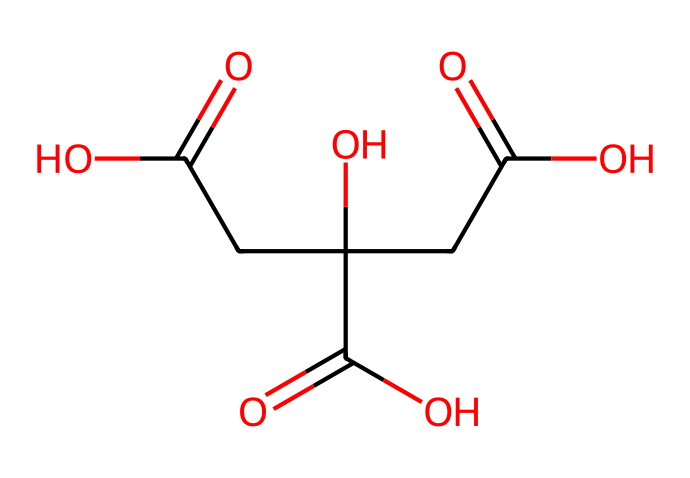What is the molecular formula of citric acid? The SMILES representation can be analyzed to determine the number of each type of atom present. Counting from the SMILES, we identify 6 carbon (C), 8 hydrogen (H), and 7 oxygen (O) atoms. Thus, the molecular formula can be written as C6H8O7.
Answer: C6H8O7 How many carboxylic acid groups are present in citric acid? By examining the structure, we can see three carboxylic acid groups (–COOH) in the citric acid molecule, indicated by the OC(=O) sections. The presence of three such functional groups confirms that citric acid is a tribasic acid.
Answer: 3 What type of isomerism is exhibited by citric acid? Citric acid shows no isomerism, as it has a specific structural arrangement without alternative forms that maintain the same molecular formula. Therefore, it is classified as a simple compound without isomers.
Answer: none What is the primary functional group in citric acid? Looking at the structure, the primary functional groups are the carboxylic acid groups, as indicated by the OC(=O) sections. These groups significantly influence the acid's properties, making it a strong acid in solution.
Answer: carboxylic acid What is the total number of hydrogen atoms attached to the structure? By analyzing the SMILES, we count a total of 8 hydrogen atoms in various functional groups, including hydroxyl (–OH) and carboxylic acid (–COOH) groups.
Answer: 8 How does citric acid contribute to the sour flavor in energy drinks? The sour flavor comes primarily from the presence of carboxylic acid groups, which release hydrogen ions (H+) in solution, leading to acidity, and thus a sour taste. This functional group's nature is responsible for the flavor profile of citric acid.
Answer: acidity 